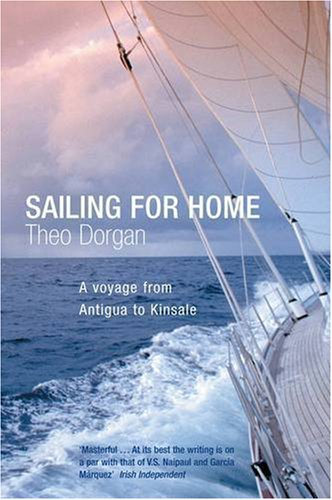Is this book related to Test Preparation? No, this book is not related to test preparation, as it predominantly explores themes of personal and maritime travel. 